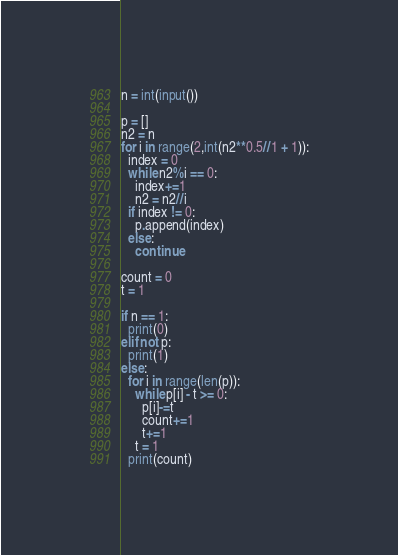Convert code to text. <code><loc_0><loc_0><loc_500><loc_500><_Python_>n = int(input())

p = []
n2 = n
for i in range(2,int(n2**0.5//1 + 1)):
  index = 0
  while n2%i == 0:
    index+=1
    n2 = n2//i
  if index != 0:
    p.append(index)
  else:
    continue

count = 0
t = 1

if n == 1:
  print(0)
elif not p:
  print(1)
else:
  for i in range(len(p)):
    while p[i] - t >= 0:
      p[i]-=t
      count+=1
      t+=1
    t = 1
  print(count)</code> 